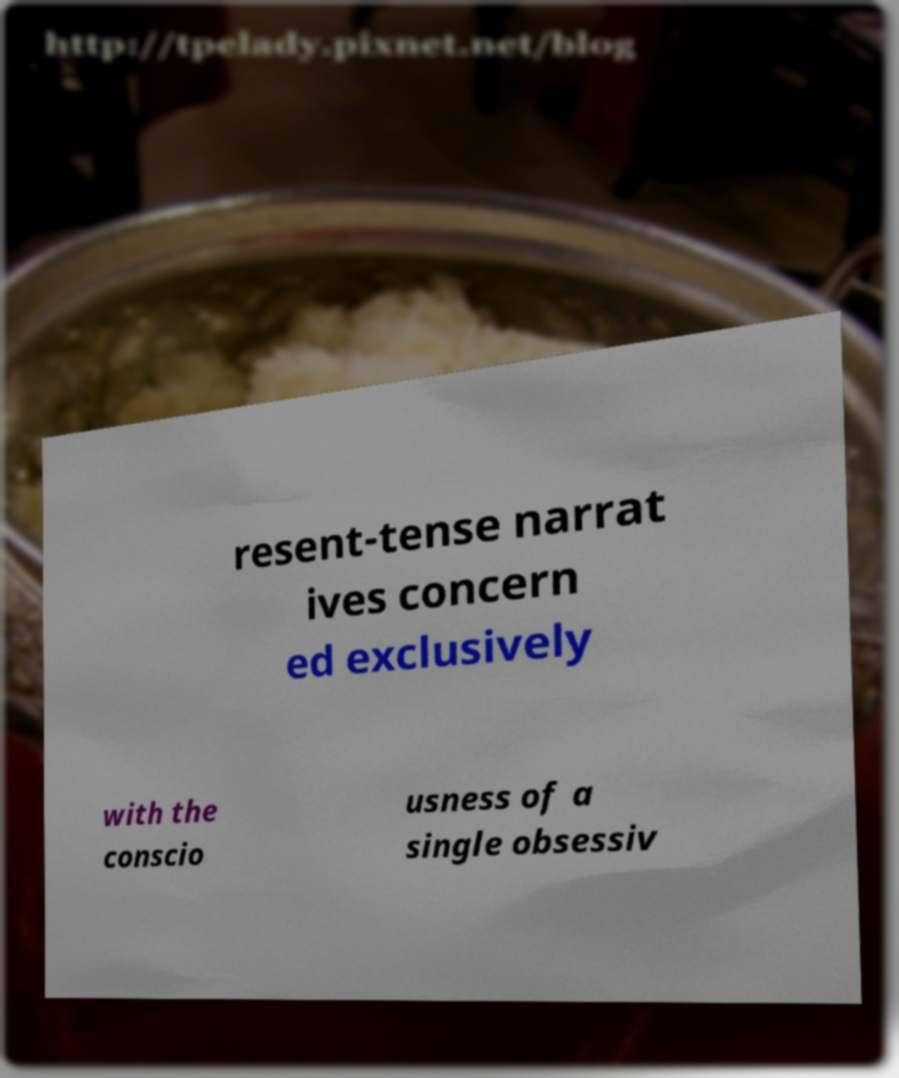Could you extract and type out the text from this image? resent-tense narrat ives concern ed exclusively with the conscio usness of a single obsessiv 